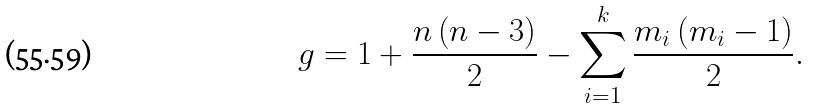Convert formula to latex. <formula><loc_0><loc_0><loc_500><loc_500>g = 1 + \frac { n \left ( n - 3 \right ) } { 2 } - \sum _ { i = 1 } ^ { k } \frac { m _ { i } \left ( m _ { i } - 1 \right ) } { 2 } .</formula> 